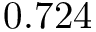<formula> <loc_0><loc_0><loc_500><loc_500>0 . 7 2 4</formula> 